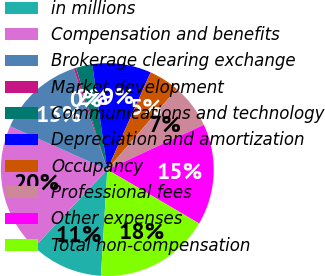<chart> <loc_0><loc_0><loc_500><loc_500><pie_chart><fcel>in millions<fcel>Compensation and benefits<fcel>Brokerage clearing exchange<fcel>Market development<fcel>Communications and technology<fcel>Depreciation and amortization<fcel>Occupancy<fcel>Professional fees<fcel>Other expenses<fcel>Total non-compensation<nl><fcel>11.07%<fcel>19.65%<fcel>13.22%<fcel>0.35%<fcel>2.5%<fcel>8.93%<fcel>4.64%<fcel>6.78%<fcel>15.36%<fcel>17.5%<nl></chart> 